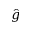<formula> <loc_0><loc_0><loc_500><loc_500>\hat { g }</formula> 